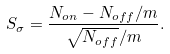Convert formula to latex. <formula><loc_0><loc_0><loc_500><loc_500>S _ { \sigma } = \frac { N _ { o n } - N _ { o f f } / m } { \sqrt { N _ { o f f } } / m } .</formula> 